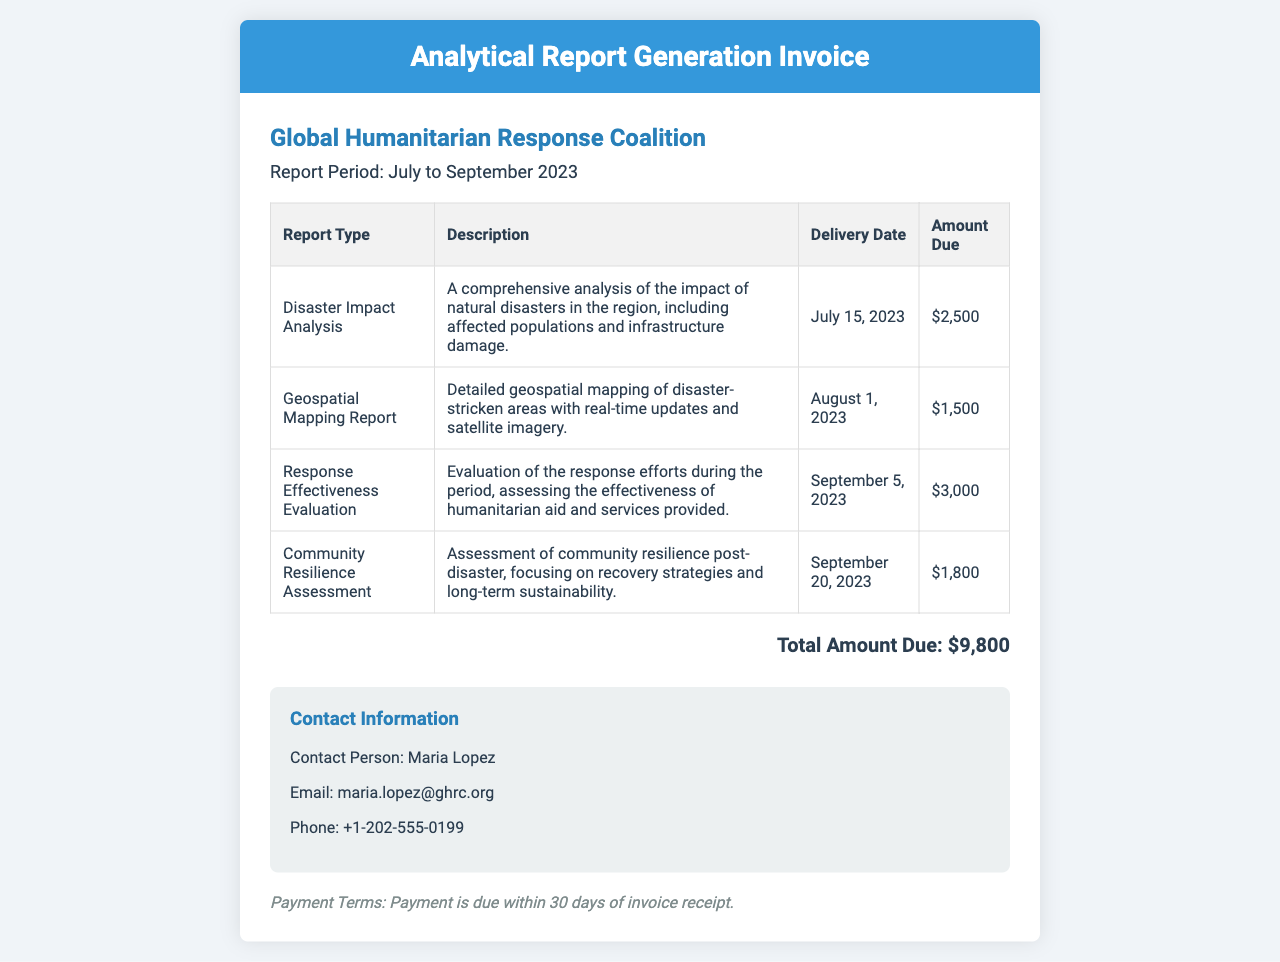What is the total amount due? The total amount due is displayed at the end of the invoice summary, which is the sum of all report amounts.
Answer: $9,800 Who is the contact person? The contact person's name is mentioned in the contact information section of the invoice.
Answer: Maria Lopez What is the delivery date for the Geospatial Mapping Report? The delivery date for the Geospatial Mapping Report is provided in the table under the corresponding report type.
Answer: August 1, 2023 How many report types are listed in the invoice? The number of report types can be determined by counting the rows in the report table.
Answer: 4 What is the description of the Community Resilience Assessment? The description is detailed in the table, providing insights into the assessment focus and content.
Answer: Assessment of community resilience post-disaster, focusing on recovery strategies and long-term sustainability When is payment due? The payment terms indicate the timeframe for payment due in connection to the receipt of the invoice.
Answer: Within 30 days of invoice receipt What type of document is this? The title at the top of the document clearly identifies the kind of document it represents.
Answer: Analytical Report Generation Invoice What report type has the highest amount due? To find this, compare the amounts in the table for each report type and identify the highest one.
Answer: Response Effectiveness Evaluation 